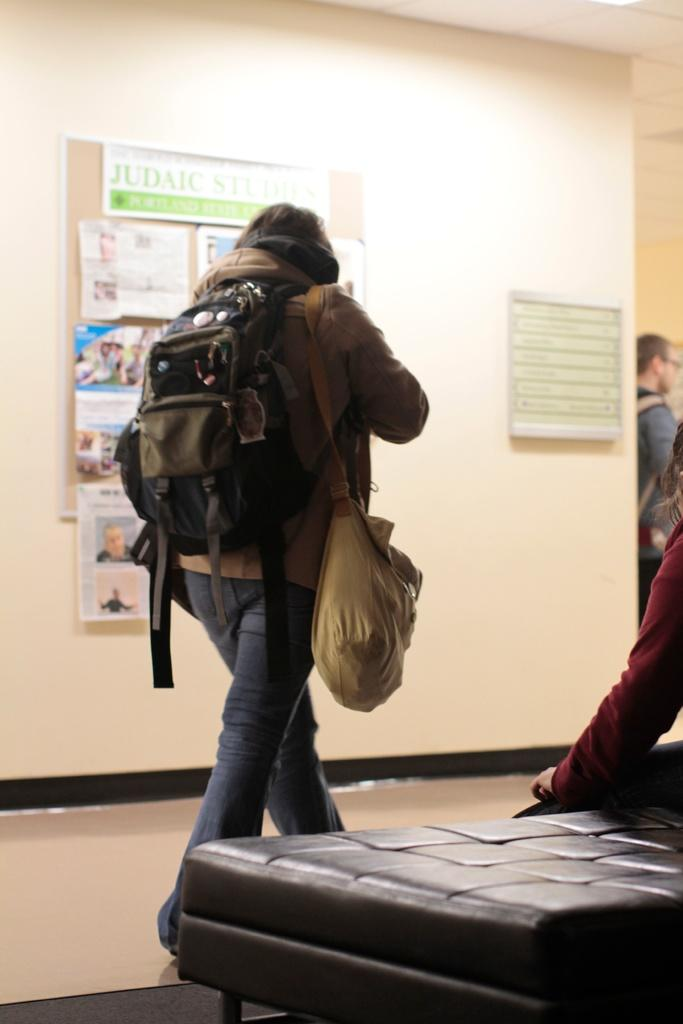What is the main action of the person in the image? There is a person walking in the image. What is the person wearing on their body? The person is wearing a bag and a jacket. What can be seen in the background of the image? There is a wall and a notice board in the background of the image. Are there any other people visible in the image? Yes, there is another person in the background of the image. What type of cloud can be seen in the image? There is no cloud visible in the image. Can you tell me how many wrens are perched on the person's shoulder in the image? There are no wrens present in the image. 